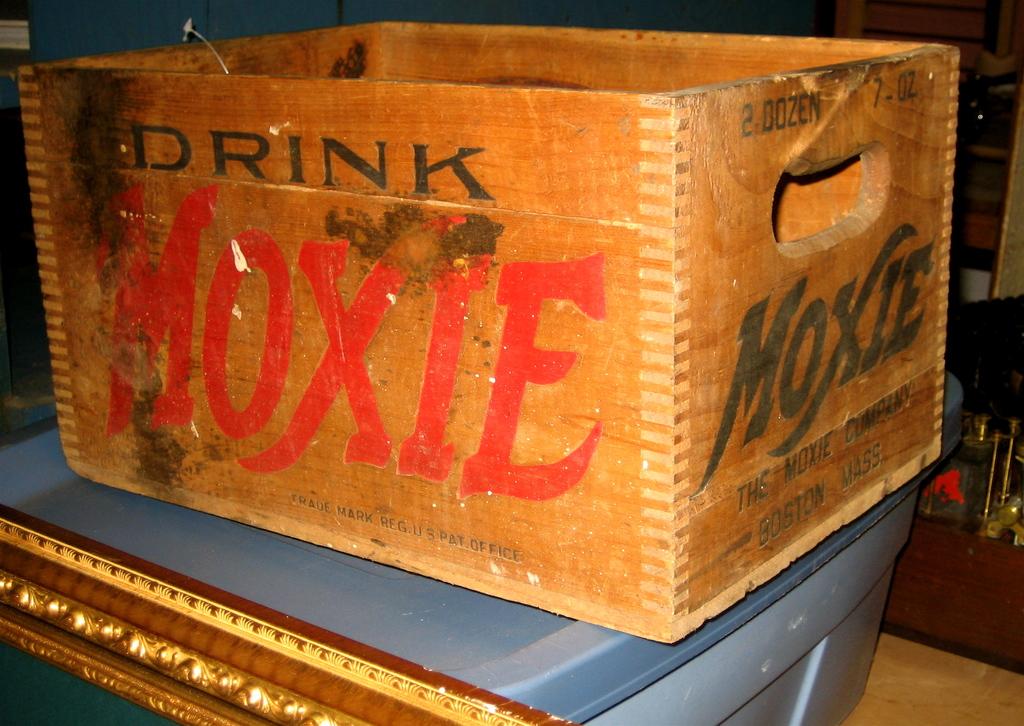What city and state are printed on the side of the box?
Offer a terse response. Moxie. 